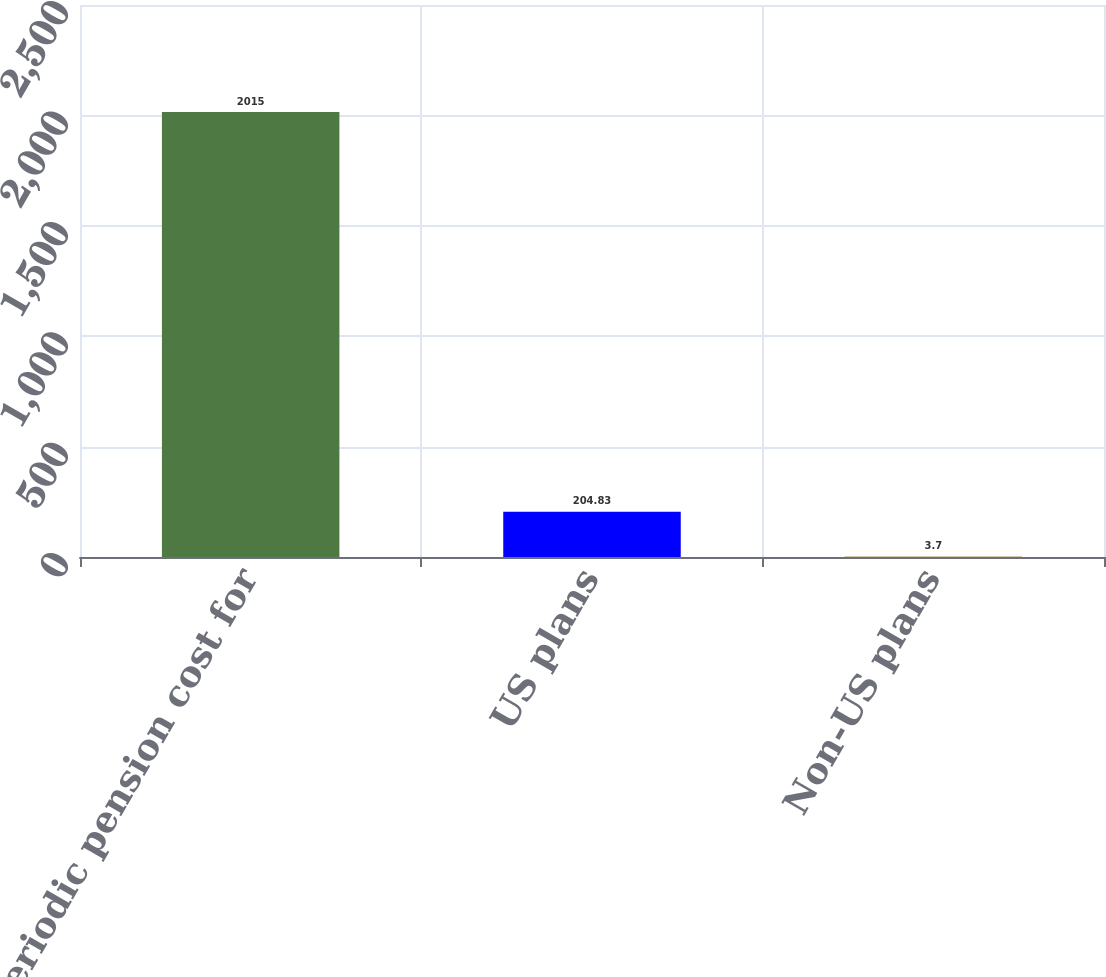Convert chart to OTSL. <chart><loc_0><loc_0><loc_500><loc_500><bar_chart><fcel>Net periodic pension cost for<fcel>US plans<fcel>Non-US plans<nl><fcel>2015<fcel>204.83<fcel>3.7<nl></chart> 